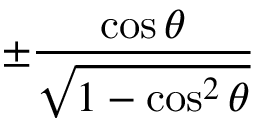Convert formula to latex. <formula><loc_0><loc_0><loc_500><loc_500>\pm { \frac { \cos \theta } { \sqrt { 1 - \cos ^ { 2 } \theta } } }</formula> 